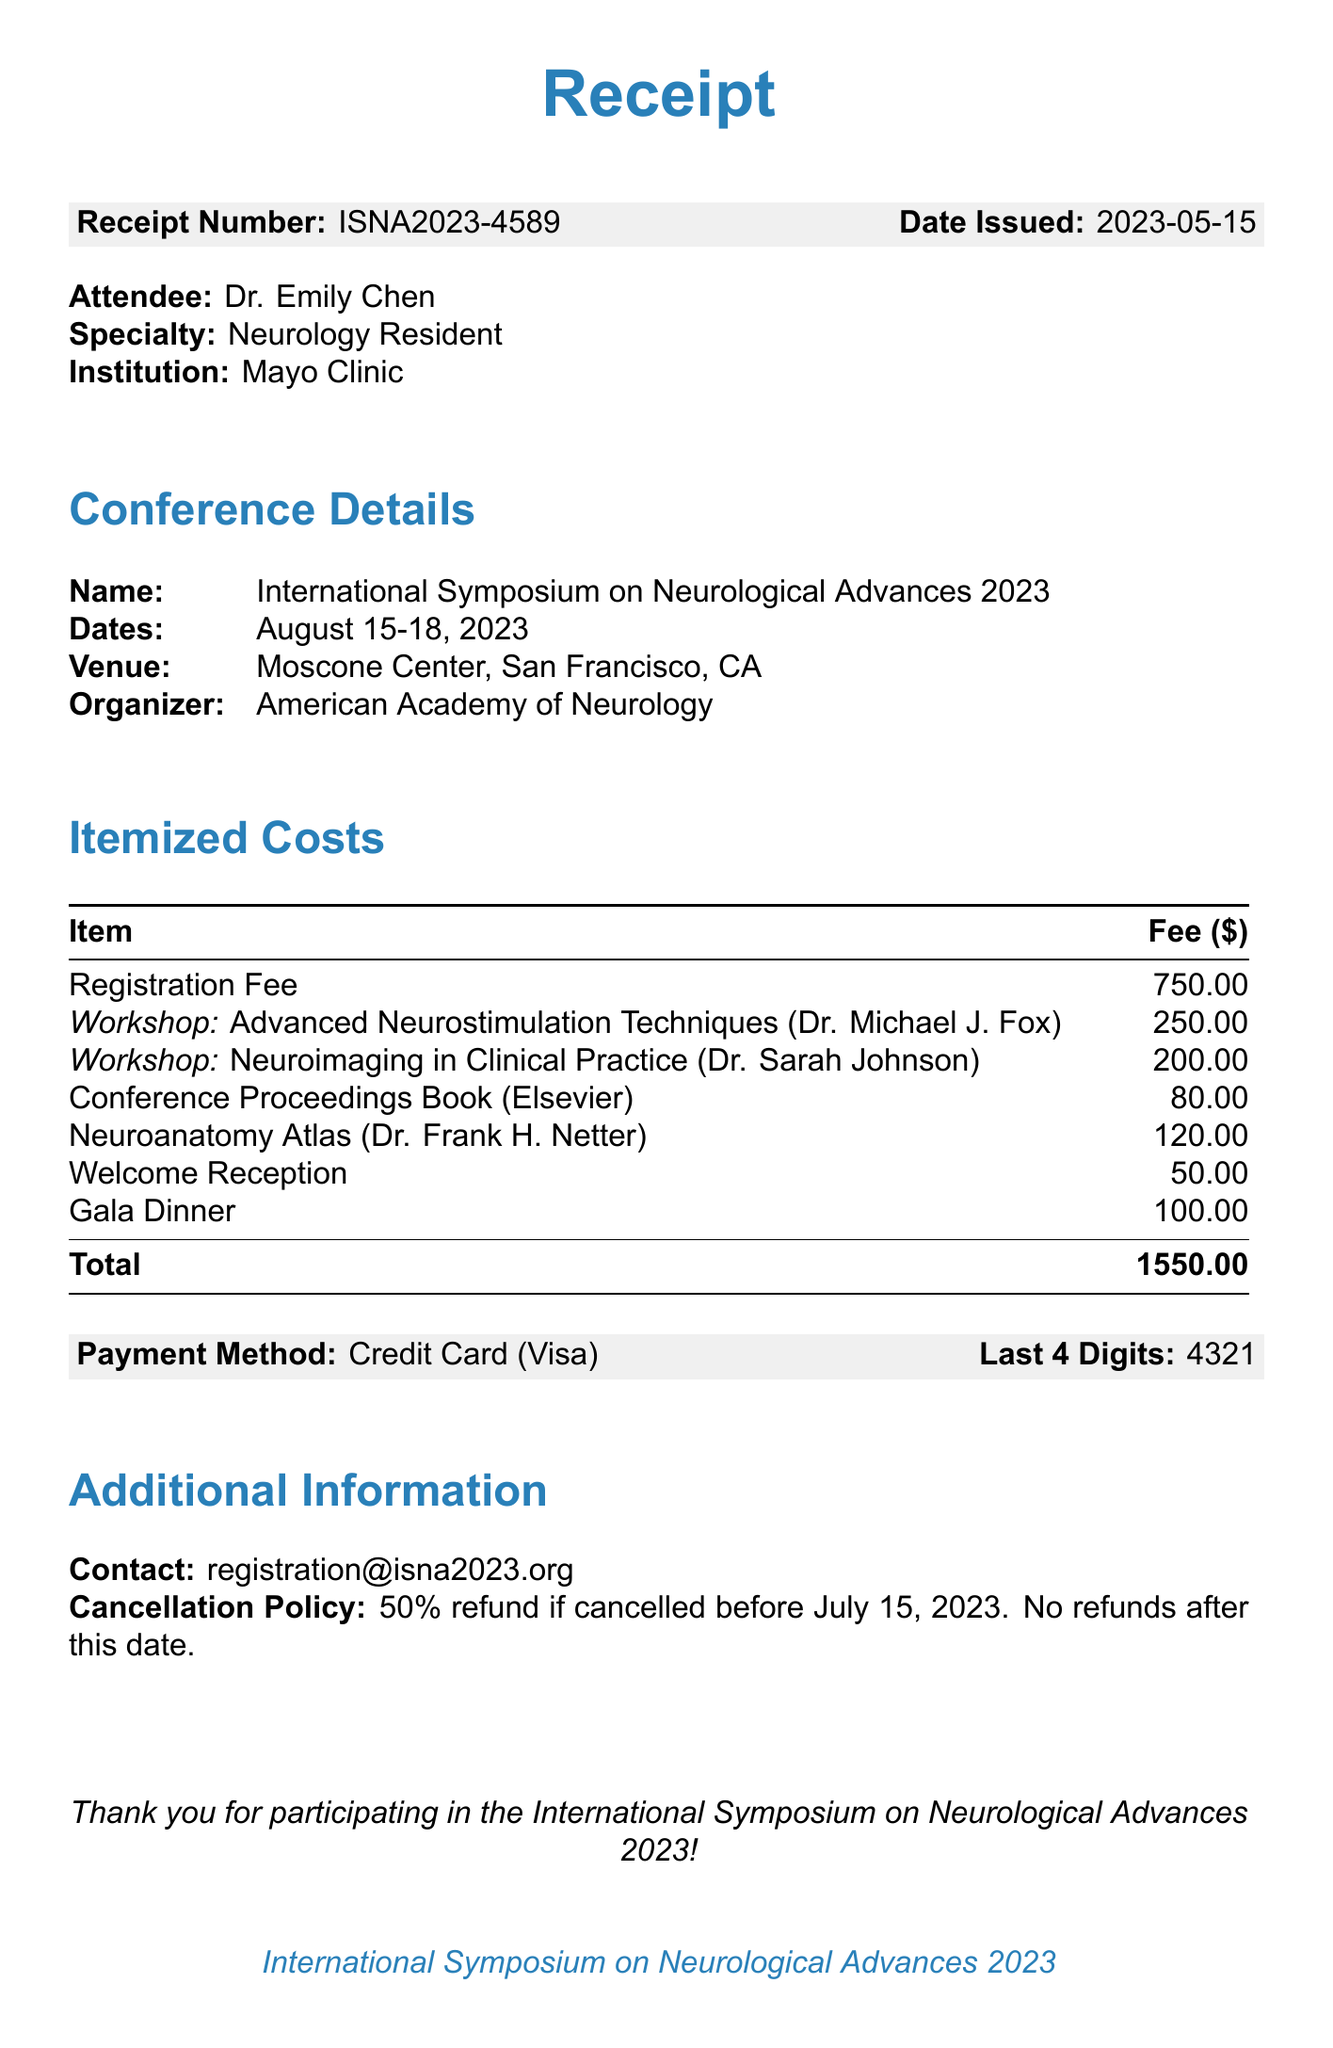What is the name of the conference? The name of the conference is stated at the beginning of the document.
Answer: International Symposium on Neurological Advances 2023 Who is the instructor for the workshop on Neuroimaging? The name of the instructor for that workshop is listed under the workshop details.
Answer: Dr. Sarah Johnson What is the fee for the Advanced Neurostimulation Techniques workshop? The fee for this workshop is provided in the itemized costs section.
Answer: 250.00 What is the total amount charged on the receipt? The document specifies the total amount at the end of the itemized costs section.
Answer: 1550.00 When was the receipt issued? The date of issuance is clearly mentioned in the document.
Answer: 2023-05-15 What is the cancellation policy regarding refunds? The cancellation policy is stated explicitly in the additional information section.
Answer: 50% refund if cancelled before July 15, 2023. No refunds after this date Where is the conference taking place? The venue information is provided in the conference details section.
Answer: Moscone Center, San Francisco, CA What is the fee for the Welcome Reception? The fee for this item is included in the additional costs listed in the document.
Answer: 50.00 